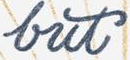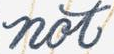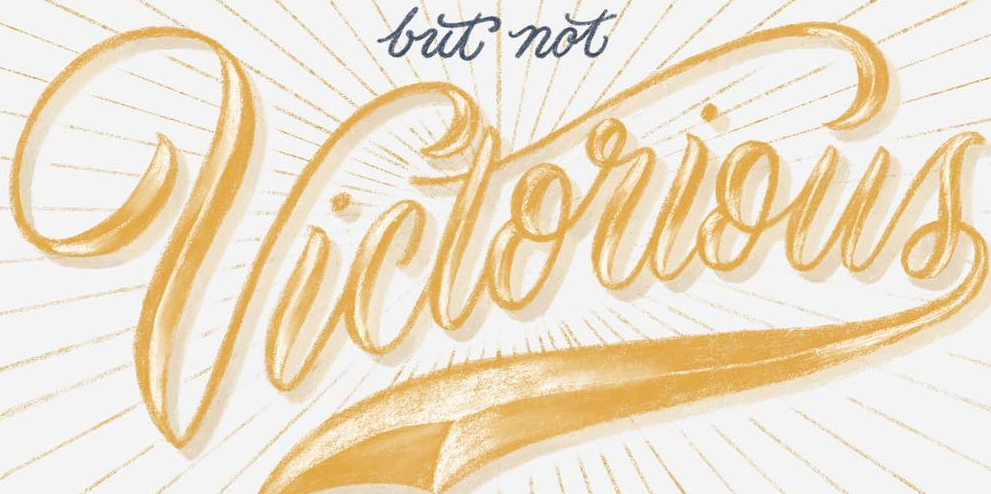What text is displayed in these images sequentially, separated by a semicolon? but; not; Victorious 